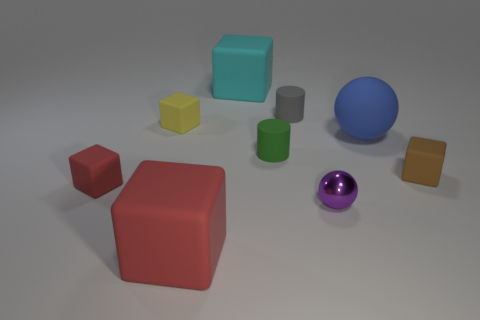Subtract all cyan cubes. How many cubes are left? 4 Add 1 green cylinders. How many objects exist? 10 Subtract all brown cubes. How many cubes are left? 4 Subtract all balls. How many objects are left? 7 Subtract 1 cylinders. How many cylinders are left? 1 Subtract all gray spheres. Subtract all gray cylinders. How many spheres are left? 2 Subtract all purple blocks. How many red balls are left? 0 Subtract all blue matte spheres. Subtract all green objects. How many objects are left? 7 Add 8 cyan rubber objects. How many cyan rubber objects are left? 9 Add 1 green shiny balls. How many green shiny balls exist? 1 